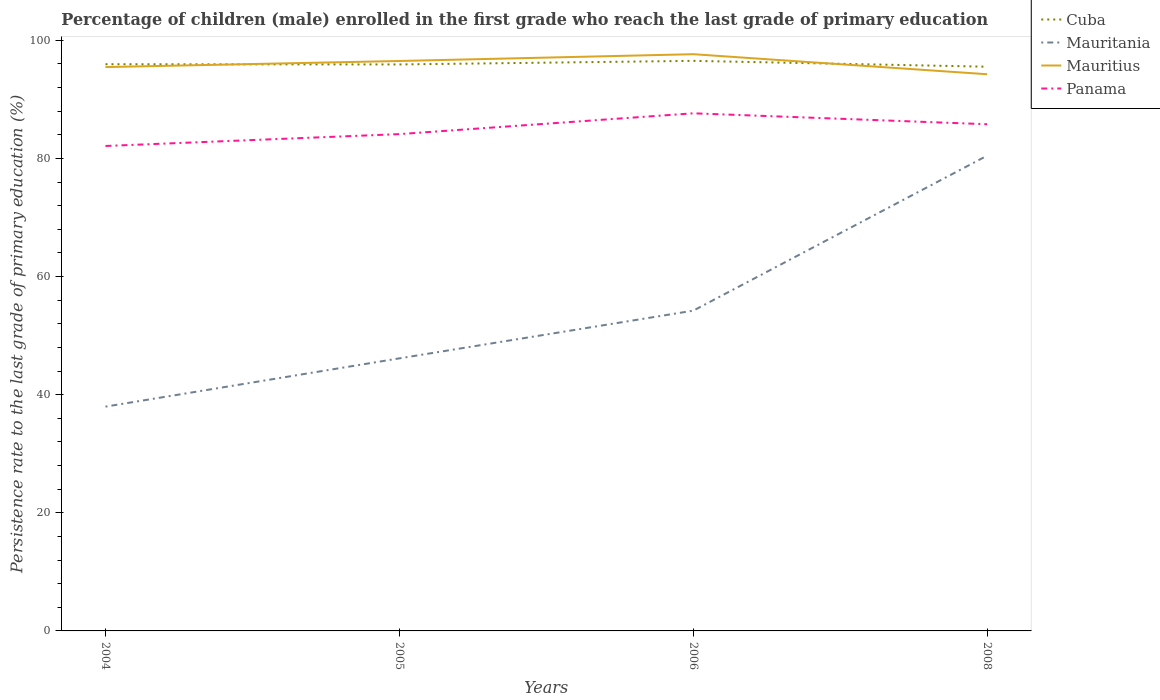Does the line corresponding to Mauritania intersect with the line corresponding to Mauritius?
Your answer should be very brief. No. Is the number of lines equal to the number of legend labels?
Provide a succinct answer. Yes. Across all years, what is the maximum persistence rate of children in Panama?
Offer a terse response. 82.1. What is the total persistence rate of children in Mauritius in the graph?
Make the answer very short. 1.21. What is the difference between the highest and the second highest persistence rate of children in Panama?
Provide a succinct answer. 5.53. Is the persistence rate of children in Mauritania strictly greater than the persistence rate of children in Panama over the years?
Provide a succinct answer. Yes. Are the values on the major ticks of Y-axis written in scientific E-notation?
Keep it short and to the point. No. Does the graph contain grids?
Your response must be concise. No. Where does the legend appear in the graph?
Your answer should be compact. Top right. What is the title of the graph?
Provide a succinct answer. Percentage of children (male) enrolled in the first grade who reach the last grade of primary education. Does "Costa Rica" appear as one of the legend labels in the graph?
Make the answer very short. No. What is the label or title of the Y-axis?
Ensure brevity in your answer.  Persistence rate to the last grade of primary education (%). What is the Persistence rate to the last grade of primary education (%) in Cuba in 2004?
Offer a terse response. 95.94. What is the Persistence rate to the last grade of primary education (%) of Mauritania in 2004?
Make the answer very short. 37.97. What is the Persistence rate to the last grade of primary education (%) of Mauritius in 2004?
Your answer should be very brief. 95.46. What is the Persistence rate to the last grade of primary education (%) in Panama in 2004?
Your answer should be compact. 82.1. What is the Persistence rate to the last grade of primary education (%) of Cuba in 2005?
Provide a short and direct response. 95.9. What is the Persistence rate to the last grade of primary education (%) in Mauritania in 2005?
Provide a short and direct response. 46.14. What is the Persistence rate to the last grade of primary education (%) of Mauritius in 2005?
Ensure brevity in your answer.  96.49. What is the Persistence rate to the last grade of primary education (%) of Panama in 2005?
Your response must be concise. 84.11. What is the Persistence rate to the last grade of primary education (%) of Cuba in 2006?
Your answer should be very brief. 96.51. What is the Persistence rate to the last grade of primary education (%) in Mauritania in 2006?
Your response must be concise. 54.22. What is the Persistence rate to the last grade of primary education (%) in Mauritius in 2006?
Provide a short and direct response. 97.64. What is the Persistence rate to the last grade of primary education (%) in Panama in 2006?
Offer a terse response. 87.63. What is the Persistence rate to the last grade of primary education (%) of Cuba in 2008?
Offer a very short reply. 95.52. What is the Persistence rate to the last grade of primary education (%) of Mauritania in 2008?
Provide a short and direct response. 80.47. What is the Persistence rate to the last grade of primary education (%) in Mauritius in 2008?
Your answer should be very brief. 94.24. What is the Persistence rate to the last grade of primary education (%) in Panama in 2008?
Provide a short and direct response. 85.78. Across all years, what is the maximum Persistence rate to the last grade of primary education (%) in Cuba?
Your answer should be very brief. 96.51. Across all years, what is the maximum Persistence rate to the last grade of primary education (%) of Mauritania?
Offer a terse response. 80.47. Across all years, what is the maximum Persistence rate to the last grade of primary education (%) in Mauritius?
Provide a succinct answer. 97.64. Across all years, what is the maximum Persistence rate to the last grade of primary education (%) of Panama?
Your answer should be very brief. 87.63. Across all years, what is the minimum Persistence rate to the last grade of primary education (%) of Cuba?
Offer a terse response. 95.52. Across all years, what is the minimum Persistence rate to the last grade of primary education (%) in Mauritania?
Give a very brief answer. 37.97. Across all years, what is the minimum Persistence rate to the last grade of primary education (%) of Mauritius?
Give a very brief answer. 94.24. Across all years, what is the minimum Persistence rate to the last grade of primary education (%) of Panama?
Offer a very short reply. 82.1. What is the total Persistence rate to the last grade of primary education (%) in Cuba in the graph?
Provide a succinct answer. 383.87. What is the total Persistence rate to the last grade of primary education (%) of Mauritania in the graph?
Make the answer very short. 218.8. What is the total Persistence rate to the last grade of primary education (%) of Mauritius in the graph?
Ensure brevity in your answer.  383.83. What is the total Persistence rate to the last grade of primary education (%) in Panama in the graph?
Ensure brevity in your answer.  339.62. What is the difference between the Persistence rate to the last grade of primary education (%) in Cuba in 2004 and that in 2005?
Provide a short and direct response. 0.04. What is the difference between the Persistence rate to the last grade of primary education (%) of Mauritania in 2004 and that in 2005?
Provide a short and direct response. -8.17. What is the difference between the Persistence rate to the last grade of primary education (%) in Mauritius in 2004 and that in 2005?
Give a very brief answer. -1.03. What is the difference between the Persistence rate to the last grade of primary education (%) of Panama in 2004 and that in 2005?
Ensure brevity in your answer.  -2.01. What is the difference between the Persistence rate to the last grade of primary education (%) in Cuba in 2004 and that in 2006?
Offer a terse response. -0.57. What is the difference between the Persistence rate to the last grade of primary education (%) of Mauritania in 2004 and that in 2006?
Offer a terse response. -16.25. What is the difference between the Persistence rate to the last grade of primary education (%) in Mauritius in 2004 and that in 2006?
Ensure brevity in your answer.  -2.18. What is the difference between the Persistence rate to the last grade of primary education (%) in Panama in 2004 and that in 2006?
Your answer should be compact. -5.53. What is the difference between the Persistence rate to the last grade of primary education (%) of Cuba in 2004 and that in 2008?
Your answer should be very brief. 0.42. What is the difference between the Persistence rate to the last grade of primary education (%) of Mauritania in 2004 and that in 2008?
Your answer should be very brief. -42.49. What is the difference between the Persistence rate to the last grade of primary education (%) of Mauritius in 2004 and that in 2008?
Your response must be concise. 1.21. What is the difference between the Persistence rate to the last grade of primary education (%) in Panama in 2004 and that in 2008?
Your response must be concise. -3.68. What is the difference between the Persistence rate to the last grade of primary education (%) in Cuba in 2005 and that in 2006?
Your answer should be very brief. -0.61. What is the difference between the Persistence rate to the last grade of primary education (%) of Mauritania in 2005 and that in 2006?
Your answer should be compact. -8.08. What is the difference between the Persistence rate to the last grade of primary education (%) in Mauritius in 2005 and that in 2006?
Provide a succinct answer. -1.15. What is the difference between the Persistence rate to the last grade of primary education (%) of Panama in 2005 and that in 2006?
Give a very brief answer. -3.52. What is the difference between the Persistence rate to the last grade of primary education (%) of Cuba in 2005 and that in 2008?
Make the answer very short. 0.38. What is the difference between the Persistence rate to the last grade of primary education (%) of Mauritania in 2005 and that in 2008?
Keep it short and to the point. -34.32. What is the difference between the Persistence rate to the last grade of primary education (%) in Mauritius in 2005 and that in 2008?
Ensure brevity in your answer.  2.25. What is the difference between the Persistence rate to the last grade of primary education (%) in Panama in 2005 and that in 2008?
Your answer should be compact. -1.67. What is the difference between the Persistence rate to the last grade of primary education (%) of Cuba in 2006 and that in 2008?
Your answer should be very brief. 0.99. What is the difference between the Persistence rate to the last grade of primary education (%) of Mauritania in 2006 and that in 2008?
Your answer should be compact. -26.25. What is the difference between the Persistence rate to the last grade of primary education (%) of Mauritius in 2006 and that in 2008?
Offer a terse response. 3.39. What is the difference between the Persistence rate to the last grade of primary education (%) in Panama in 2006 and that in 2008?
Your answer should be very brief. 1.85. What is the difference between the Persistence rate to the last grade of primary education (%) of Cuba in 2004 and the Persistence rate to the last grade of primary education (%) of Mauritania in 2005?
Offer a very short reply. 49.8. What is the difference between the Persistence rate to the last grade of primary education (%) of Cuba in 2004 and the Persistence rate to the last grade of primary education (%) of Mauritius in 2005?
Your response must be concise. -0.55. What is the difference between the Persistence rate to the last grade of primary education (%) in Cuba in 2004 and the Persistence rate to the last grade of primary education (%) in Panama in 2005?
Your response must be concise. 11.83. What is the difference between the Persistence rate to the last grade of primary education (%) in Mauritania in 2004 and the Persistence rate to the last grade of primary education (%) in Mauritius in 2005?
Provide a short and direct response. -58.52. What is the difference between the Persistence rate to the last grade of primary education (%) of Mauritania in 2004 and the Persistence rate to the last grade of primary education (%) of Panama in 2005?
Give a very brief answer. -46.14. What is the difference between the Persistence rate to the last grade of primary education (%) in Mauritius in 2004 and the Persistence rate to the last grade of primary education (%) in Panama in 2005?
Make the answer very short. 11.35. What is the difference between the Persistence rate to the last grade of primary education (%) of Cuba in 2004 and the Persistence rate to the last grade of primary education (%) of Mauritania in 2006?
Keep it short and to the point. 41.72. What is the difference between the Persistence rate to the last grade of primary education (%) in Cuba in 2004 and the Persistence rate to the last grade of primary education (%) in Mauritius in 2006?
Your response must be concise. -1.7. What is the difference between the Persistence rate to the last grade of primary education (%) in Cuba in 2004 and the Persistence rate to the last grade of primary education (%) in Panama in 2006?
Offer a terse response. 8.31. What is the difference between the Persistence rate to the last grade of primary education (%) in Mauritania in 2004 and the Persistence rate to the last grade of primary education (%) in Mauritius in 2006?
Provide a succinct answer. -59.66. What is the difference between the Persistence rate to the last grade of primary education (%) in Mauritania in 2004 and the Persistence rate to the last grade of primary education (%) in Panama in 2006?
Your answer should be compact. -49.66. What is the difference between the Persistence rate to the last grade of primary education (%) of Mauritius in 2004 and the Persistence rate to the last grade of primary education (%) of Panama in 2006?
Your response must be concise. 7.82. What is the difference between the Persistence rate to the last grade of primary education (%) of Cuba in 2004 and the Persistence rate to the last grade of primary education (%) of Mauritania in 2008?
Your answer should be compact. 15.48. What is the difference between the Persistence rate to the last grade of primary education (%) of Cuba in 2004 and the Persistence rate to the last grade of primary education (%) of Mauritius in 2008?
Provide a succinct answer. 1.7. What is the difference between the Persistence rate to the last grade of primary education (%) of Cuba in 2004 and the Persistence rate to the last grade of primary education (%) of Panama in 2008?
Ensure brevity in your answer.  10.16. What is the difference between the Persistence rate to the last grade of primary education (%) in Mauritania in 2004 and the Persistence rate to the last grade of primary education (%) in Mauritius in 2008?
Your answer should be very brief. -56.27. What is the difference between the Persistence rate to the last grade of primary education (%) in Mauritania in 2004 and the Persistence rate to the last grade of primary education (%) in Panama in 2008?
Make the answer very short. -47.81. What is the difference between the Persistence rate to the last grade of primary education (%) in Mauritius in 2004 and the Persistence rate to the last grade of primary education (%) in Panama in 2008?
Provide a short and direct response. 9.67. What is the difference between the Persistence rate to the last grade of primary education (%) in Cuba in 2005 and the Persistence rate to the last grade of primary education (%) in Mauritania in 2006?
Make the answer very short. 41.68. What is the difference between the Persistence rate to the last grade of primary education (%) of Cuba in 2005 and the Persistence rate to the last grade of primary education (%) of Mauritius in 2006?
Offer a terse response. -1.74. What is the difference between the Persistence rate to the last grade of primary education (%) in Cuba in 2005 and the Persistence rate to the last grade of primary education (%) in Panama in 2006?
Provide a succinct answer. 8.27. What is the difference between the Persistence rate to the last grade of primary education (%) of Mauritania in 2005 and the Persistence rate to the last grade of primary education (%) of Mauritius in 2006?
Give a very brief answer. -51.49. What is the difference between the Persistence rate to the last grade of primary education (%) of Mauritania in 2005 and the Persistence rate to the last grade of primary education (%) of Panama in 2006?
Give a very brief answer. -41.49. What is the difference between the Persistence rate to the last grade of primary education (%) of Mauritius in 2005 and the Persistence rate to the last grade of primary education (%) of Panama in 2006?
Provide a short and direct response. 8.86. What is the difference between the Persistence rate to the last grade of primary education (%) in Cuba in 2005 and the Persistence rate to the last grade of primary education (%) in Mauritania in 2008?
Give a very brief answer. 15.44. What is the difference between the Persistence rate to the last grade of primary education (%) in Cuba in 2005 and the Persistence rate to the last grade of primary education (%) in Mauritius in 2008?
Your answer should be very brief. 1.66. What is the difference between the Persistence rate to the last grade of primary education (%) in Cuba in 2005 and the Persistence rate to the last grade of primary education (%) in Panama in 2008?
Give a very brief answer. 10.12. What is the difference between the Persistence rate to the last grade of primary education (%) in Mauritania in 2005 and the Persistence rate to the last grade of primary education (%) in Mauritius in 2008?
Offer a very short reply. -48.1. What is the difference between the Persistence rate to the last grade of primary education (%) in Mauritania in 2005 and the Persistence rate to the last grade of primary education (%) in Panama in 2008?
Your answer should be compact. -39.64. What is the difference between the Persistence rate to the last grade of primary education (%) in Mauritius in 2005 and the Persistence rate to the last grade of primary education (%) in Panama in 2008?
Keep it short and to the point. 10.71. What is the difference between the Persistence rate to the last grade of primary education (%) in Cuba in 2006 and the Persistence rate to the last grade of primary education (%) in Mauritania in 2008?
Your answer should be compact. 16.04. What is the difference between the Persistence rate to the last grade of primary education (%) in Cuba in 2006 and the Persistence rate to the last grade of primary education (%) in Mauritius in 2008?
Give a very brief answer. 2.27. What is the difference between the Persistence rate to the last grade of primary education (%) in Cuba in 2006 and the Persistence rate to the last grade of primary education (%) in Panama in 2008?
Your answer should be compact. 10.73. What is the difference between the Persistence rate to the last grade of primary education (%) of Mauritania in 2006 and the Persistence rate to the last grade of primary education (%) of Mauritius in 2008?
Your answer should be compact. -40.02. What is the difference between the Persistence rate to the last grade of primary education (%) of Mauritania in 2006 and the Persistence rate to the last grade of primary education (%) of Panama in 2008?
Your answer should be compact. -31.56. What is the difference between the Persistence rate to the last grade of primary education (%) in Mauritius in 2006 and the Persistence rate to the last grade of primary education (%) in Panama in 2008?
Offer a very short reply. 11.86. What is the average Persistence rate to the last grade of primary education (%) in Cuba per year?
Make the answer very short. 95.97. What is the average Persistence rate to the last grade of primary education (%) of Mauritania per year?
Ensure brevity in your answer.  54.7. What is the average Persistence rate to the last grade of primary education (%) of Mauritius per year?
Ensure brevity in your answer.  95.96. What is the average Persistence rate to the last grade of primary education (%) in Panama per year?
Ensure brevity in your answer.  84.91. In the year 2004, what is the difference between the Persistence rate to the last grade of primary education (%) in Cuba and Persistence rate to the last grade of primary education (%) in Mauritania?
Ensure brevity in your answer.  57.97. In the year 2004, what is the difference between the Persistence rate to the last grade of primary education (%) of Cuba and Persistence rate to the last grade of primary education (%) of Mauritius?
Keep it short and to the point. 0.49. In the year 2004, what is the difference between the Persistence rate to the last grade of primary education (%) in Cuba and Persistence rate to the last grade of primary education (%) in Panama?
Ensure brevity in your answer.  13.84. In the year 2004, what is the difference between the Persistence rate to the last grade of primary education (%) in Mauritania and Persistence rate to the last grade of primary education (%) in Mauritius?
Make the answer very short. -57.48. In the year 2004, what is the difference between the Persistence rate to the last grade of primary education (%) in Mauritania and Persistence rate to the last grade of primary education (%) in Panama?
Provide a succinct answer. -44.13. In the year 2004, what is the difference between the Persistence rate to the last grade of primary education (%) in Mauritius and Persistence rate to the last grade of primary education (%) in Panama?
Your answer should be compact. 13.36. In the year 2005, what is the difference between the Persistence rate to the last grade of primary education (%) of Cuba and Persistence rate to the last grade of primary education (%) of Mauritania?
Keep it short and to the point. 49.76. In the year 2005, what is the difference between the Persistence rate to the last grade of primary education (%) of Cuba and Persistence rate to the last grade of primary education (%) of Mauritius?
Your answer should be compact. -0.59. In the year 2005, what is the difference between the Persistence rate to the last grade of primary education (%) of Cuba and Persistence rate to the last grade of primary education (%) of Panama?
Offer a terse response. 11.79. In the year 2005, what is the difference between the Persistence rate to the last grade of primary education (%) in Mauritania and Persistence rate to the last grade of primary education (%) in Mauritius?
Provide a short and direct response. -50.34. In the year 2005, what is the difference between the Persistence rate to the last grade of primary education (%) in Mauritania and Persistence rate to the last grade of primary education (%) in Panama?
Provide a succinct answer. -37.96. In the year 2005, what is the difference between the Persistence rate to the last grade of primary education (%) of Mauritius and Persistence rate to the last grade of primary education (%) of Panama?
Provide a short and direct response. 12.38. In the year 2006, what is the difference between the Persistence rate to the last grade of primary education (%) of Cuba and Persistence rate to the last grade of primary education (%) of Mauritania?
Offer a terse response. 42.29. In the year 2006, what is the difference between the Persistence rate to the last grade of primary education (%) of Cuba and Persistence rate to the last grade of primary education (%) of Mauritius?
Your answer should be compact. -1.13. In the year 2006, what is the difference between the Persistence rate to the last grade of primary education (%) in Cuba and Persistence rate to the last grade of primary education (%) in Panama?
Provide a short and direct response. 8.88. In the year 2006, what is the difference between the Persistence rate to the last grade of primary education (%) of Mauritania and Persistence rate to the last grade of primary education (%) of Mauritius?
Your answer should be compact. -43.42. In the year 2006, what is the difference between the Persistence rate to the last grade of primary education (%) in Mauritania and Persistence rate to the last grade of primary education (%) in Panama?
Offer a terse response. -33.41. In the year 2006, what is the difference between the Persistence rate to the last grade of primary education (%) in Mauritius and Persistence rate to the last grade of primary education (%) in Panama?
Offer a very short reply. 10.01. In the year 2008, what is the difference between the Persistence rate to the last grade of primary education (%) in Cuba and Persistence rate to the last grade of primary education (%) in Mauritania?
Your response must be concise. 15.05. In the year 2008, what is the difference between the Persistence rate to the last grade of primary education (%) in Cuba and Persistence rate to the last grade of primary education (%) in Mauritius?
Your response must be concise. 1.27. In the year 2008, what is the difference between the Persistence rate to the last grade of primary education (%) of Cuba and Persistence rate to the last grade of primary education (%) of Panama?
Your answer should be compact. 9.74. In the year 2008, what is the difference between the Persistence rate to the last grade of primary education (%) of Mauritania and Persistence rate to the last grade of primary education (%) of Mauritius?
Provide a short and direct response. -13.78. In the year 2008, what is the difference between the Persistence rate to the last grade of primary education (%) of Mauritania and Persistence rate to the last grade of primary education (%) of Panama?
Provide a succinct answer. -5.32. In the year 2008, what is the difference between the Persistence rate to the last grade of primary education (%) in Mauritius and Persistence rate to the last grade of primary education (%) in Panama?
Offer a terse response. 8.46. What is the ratio of the Persistence rate to the last grade of primary education (%) of Cuba in 2004 to that in 2005?
Provide a succinct answer. 1. What is the ratio of the Persistence rate to the last grade of primary education (%) of Mauritania in 2004 to that in 2005?
Keep it short and to the point. 0.82. What is the ratio of the Persistence rate to the last grade of primary education (%) in Mauritius in 2004 to that in 2005?
Your answer should be compact. 0.99. What is the ratio of the Persistence rate to the last grade of primary education (%) in Panama in 2004 to that in 2005?
Your answer should be very brief. 0.98. What is the ratio of the Persistence rate to the last grade of primary education (%) of Mauritania in 2004 to that in 2006?
Make the answer very short. 0.7. What is the ratio of the Persistence rate to the last grade of primary education (%) of Mauritius in 2004 to that in 2006?
Offer a terse response. 0.98. What is the ratio of the Persistence rate to the last grade of primary education (%) of Panama in 2004 to that in 2006?
Ensure brevity in your answer.  0.94. What is the ratio of the Persistence rate to the last grade of primary education (%) of Cuba in 2004 to that in 2008?
Your response must be concise. 1. What is the ratio of the Persistence rate to the last grade of primary education (%) of Mauritania in 2004 to that in 2008?
Your answer should be compact. 0.47. What is the ratio of the Persistence rate to the last grade of primary education (%) in Mauritius in 2004 to that in 2008?
Provide a succinct answer. 1.01. What is the ratio of the Persistence rate to the last grade of primary education (%) in Panama in 2004 to that in 2008?
Offer a terse response. 0.96. What is the ratio of the Persistence rate to the last grade of primary education (%) in Mauritania in 2005 to that in 2006?
Your answer should be very brief. 0.85. What is the ratio of the Persistence rate to the last grade of primary education (%) of Mauritius in 2005 to that in 2006?
Your answer should be compact. 0.99. What is the ratio of the Persistence rate to the last grade of primary education (%) in Panama in 2005 to that in 2006?
Provide a short and direct response. 0.96. What is the ratio of the Persistence rate to the last grade of primary education (%) of Mauritania in 2005 to that in 2008?
Keep it short and to the point. 0.57. What is the ratio of the Persistence rate to the last grade of primary education (%) of Mauritius in 2005 to that in 2008?
Offer a terse response. 1.02. What is the ratio of the Persistence rate to the last grade of primary education (%) of Panama in 2005 to that in 2008?
Provide a succinct answer. 0.98. What is the ratio of the Persistence rate to the last grade of primary education (%) of Cuba in 2006 to that in 2008?
Provide a short and direct response. 1.01. What is the ratio of the Persistence rate to the last grade of primary education (%) in Mauritania in 2006 to that in 2008?
Give a very brief answer. 0.67. What is the ratio of the Persistence rate to the last grade of primary education (%) of Mauritius in 2006 to that in 2008?
Your answer should be very brief. 1.04. What is the ratio of the Persistence rate to the last grade of primary education (%) of Panama in 2006 to that in 2008?
Keep it short and to the point. 1.02. What is the difference between the highest and the second highest Persistence rate to the last grade of primary education (%) in Cuba?
Offer a very short reply. 0.57. What is the difference between the highest and the second highest Persistence rate to the last grade of primary education (%) of Mauritania?
Your response must be concise. 26.25. What is the difference between the highest and the second highest Persistence rate to the last grade of primary education (%) in Mauritius?
Make the answer very short. 1.15. What is the difference between the highest and the second highest Persistence rate to the last grade of primary education (%) in Panama?
Ensure brevity in your answer.  1.85. What is the difference between the highest and the lowest Persistence rate to the last grade of primary education (%) of Cuba?
Provide a short and direct response. 0.99. What is the difference between the highest and the lowest Persistence rate to the last grade of primary education (%) in Mauritania?
Your response must be concise. 42.49. What is the difference between the highest and the lowest Persistence rate to the last grade of primary education (%) of Mauritius?
Give a very brief answer. 3.39. What is the difference between the highest and the lowest Persistence rate to the last grade of primary education (%) in Panama?
Your answer should be compact. 5.53. 